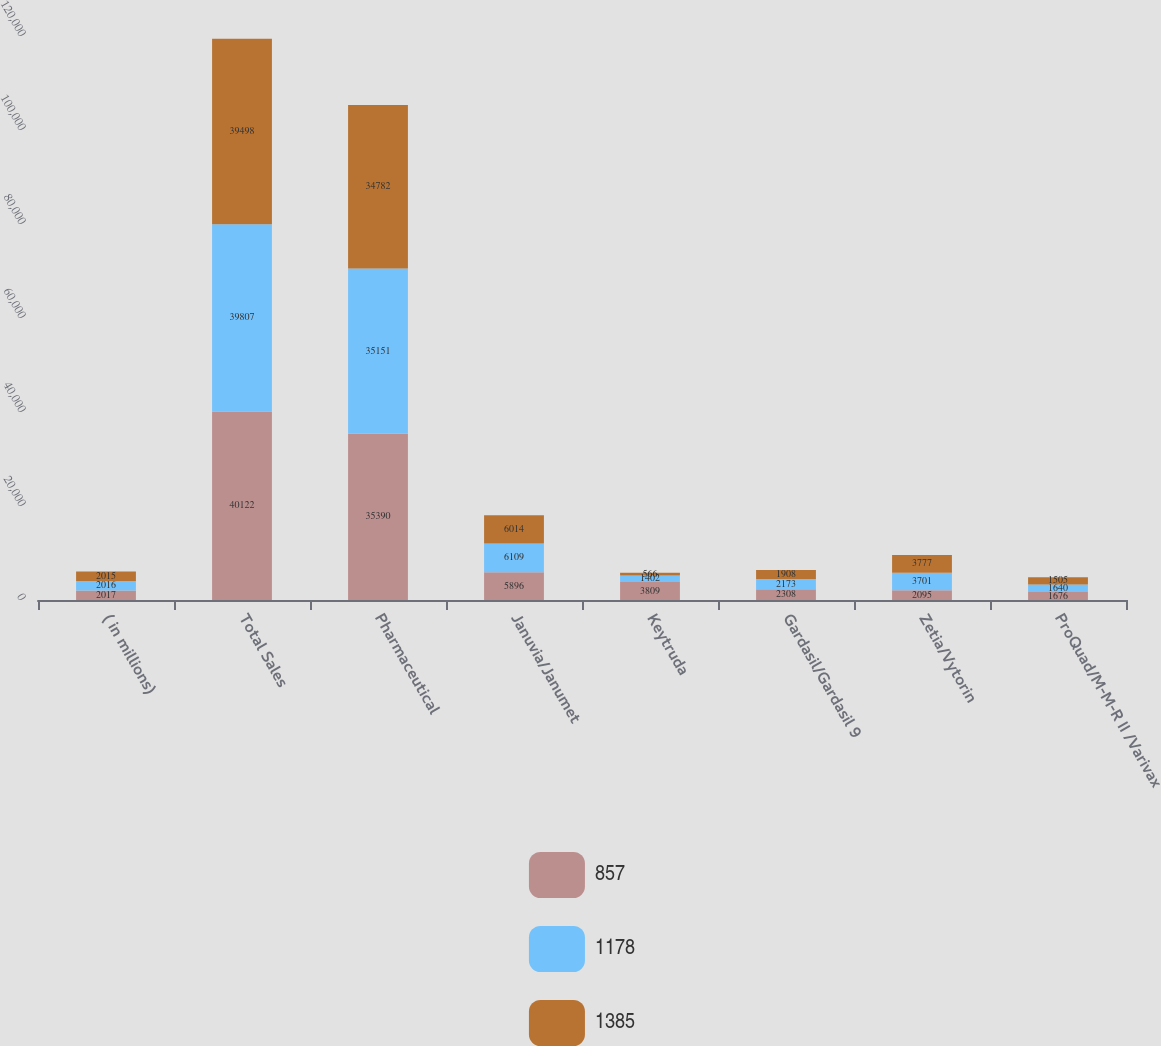Convert chart to OTSL. <chart><loc_0><loc_0><loc_500><loc_500><stacked_bar_chart><ecel><fcel>( in millions)<fcel>Total Sales<fcel>Pharmaceutical<fcel>Januvia/Janumet<fcel>Keytruda<fcel>Gardasil/Gardasil 9<fcel>Zetia/Vytorin<fcel>ProQuad/M-M-R II /Varivax<nl><fcel>857<fcel>2017<fcel>40122<fcel>35390<fcel>5896<fcel>3809<fcel>2308<fcel>2095<fcel>1676<nl><fcel>1178<fcel>2016<fcel>39807<fcel>35151<fcel>6109<fcel>1402<fcel>2173<fcel>3701<fcel>1640<nl><fcel>1385<fcel>2015<fcel>39498<fcel>34782<fcel>6014<fcel>566<fcel>1908<fcel>3777<fcel>1505<nl></chart> 